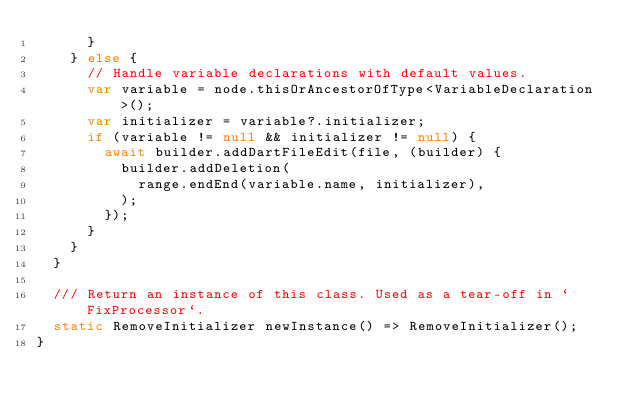Convert code to text. <code><loc_0><loc_0><loc_500><loc_500><_Dart_>      }
    } else {
      // Handle variable declarations with default values.
      var variable = node.thisOrAncestorOfType<VariableDeclaration>();
      var initializer = variable?.initializer;
      if (variable != null && initializer != null) {
        await builder.addDartFileEdit(file, (builder) {
          builder.addDeletion(
            range.endEnd(variable.name, initializer),
          );
        });
      }
    }
  }

  /// Return an instance of this class. Used as a tear-off in `FixProcessor`.
  static RemoveInitializer newInstance() => RemoveInitializer();
}
</code> 